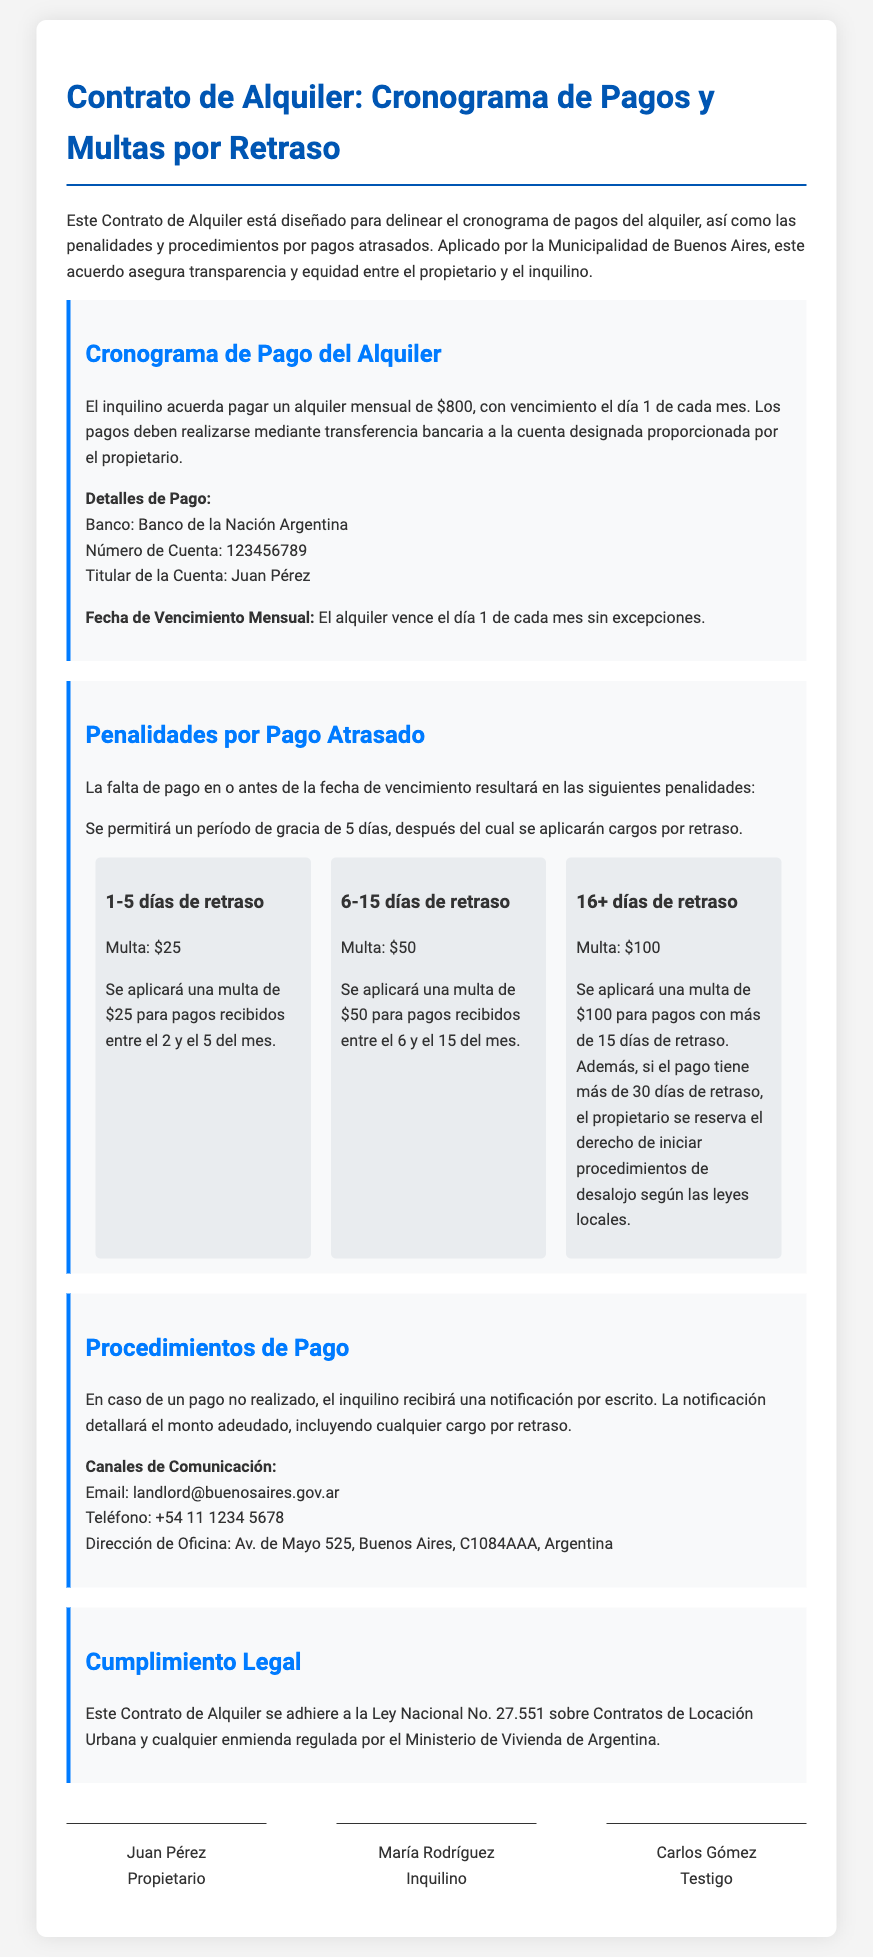what is the monthly rent amount? The monthly rent amount is specified in the document as $800.
Answer: $800 who is the account holder for the rent payments? The document specifies that the account holder for the rent payments is Juan Pérez.
Answer: Juan Pérez how many days of grace are allowed for late payment? The document states that a grace period of 5 days is allowed for late payment.
Answer: 5 days what is the penalty for a payment that is 6-15 days late? The document indicates that the penalty for a payment that is 6-15 days late is $50.
Answer: $50 what happens if the payment is more than 30 days late? According to the document, if the payment is more than 30 days late, the owner reserves the right to initiate eviction procedures.
Answer: initiate eviction procedures what notification will the tenant receive in case of a missed payment? The document mentions that the tenant will receive a written notification detailing the amount owed and any late charges.
Answer: written notification what is the bank name for the rental payments? The document specifies that the bank for the rental payments is Banco de la Nación Argentina.
Answer: Banco de la Nación Argentina what is the address of the landlord's office? The document provides the address of the landlord's office as Av. de Mayo 525, Buenos Aires, C1084AAA, Argentina.
Answer: Av. de Mayo 525, Buenos Aires, C1084AAA, Argentina who are the parties involved in the lease agreement? The lease agreement identifies Juan Pérez as the owner and María Rodríguez as the tenant.
Answer: Juan Pérez and María Rodríguez 